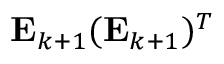Convert formula to latex. <formula><loc_0><loc_0><loc_500><loc_500>E _ { k + 1 } ( E _ { k + 1 } ) ^ { T }</formula> 